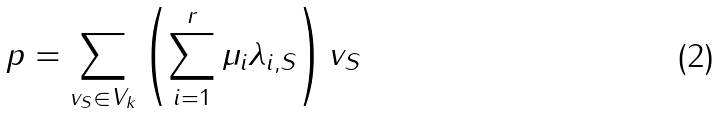<formula> <loc_0><loc_0><loc_500><loc_500>p = \sum _ { v _ { S } \in V _ { k } } \left ( \sum _ { i = 1 } ^ { r } \mu _ { i } \lambda _ { i , S } \right ) v _ { S }</formula> 